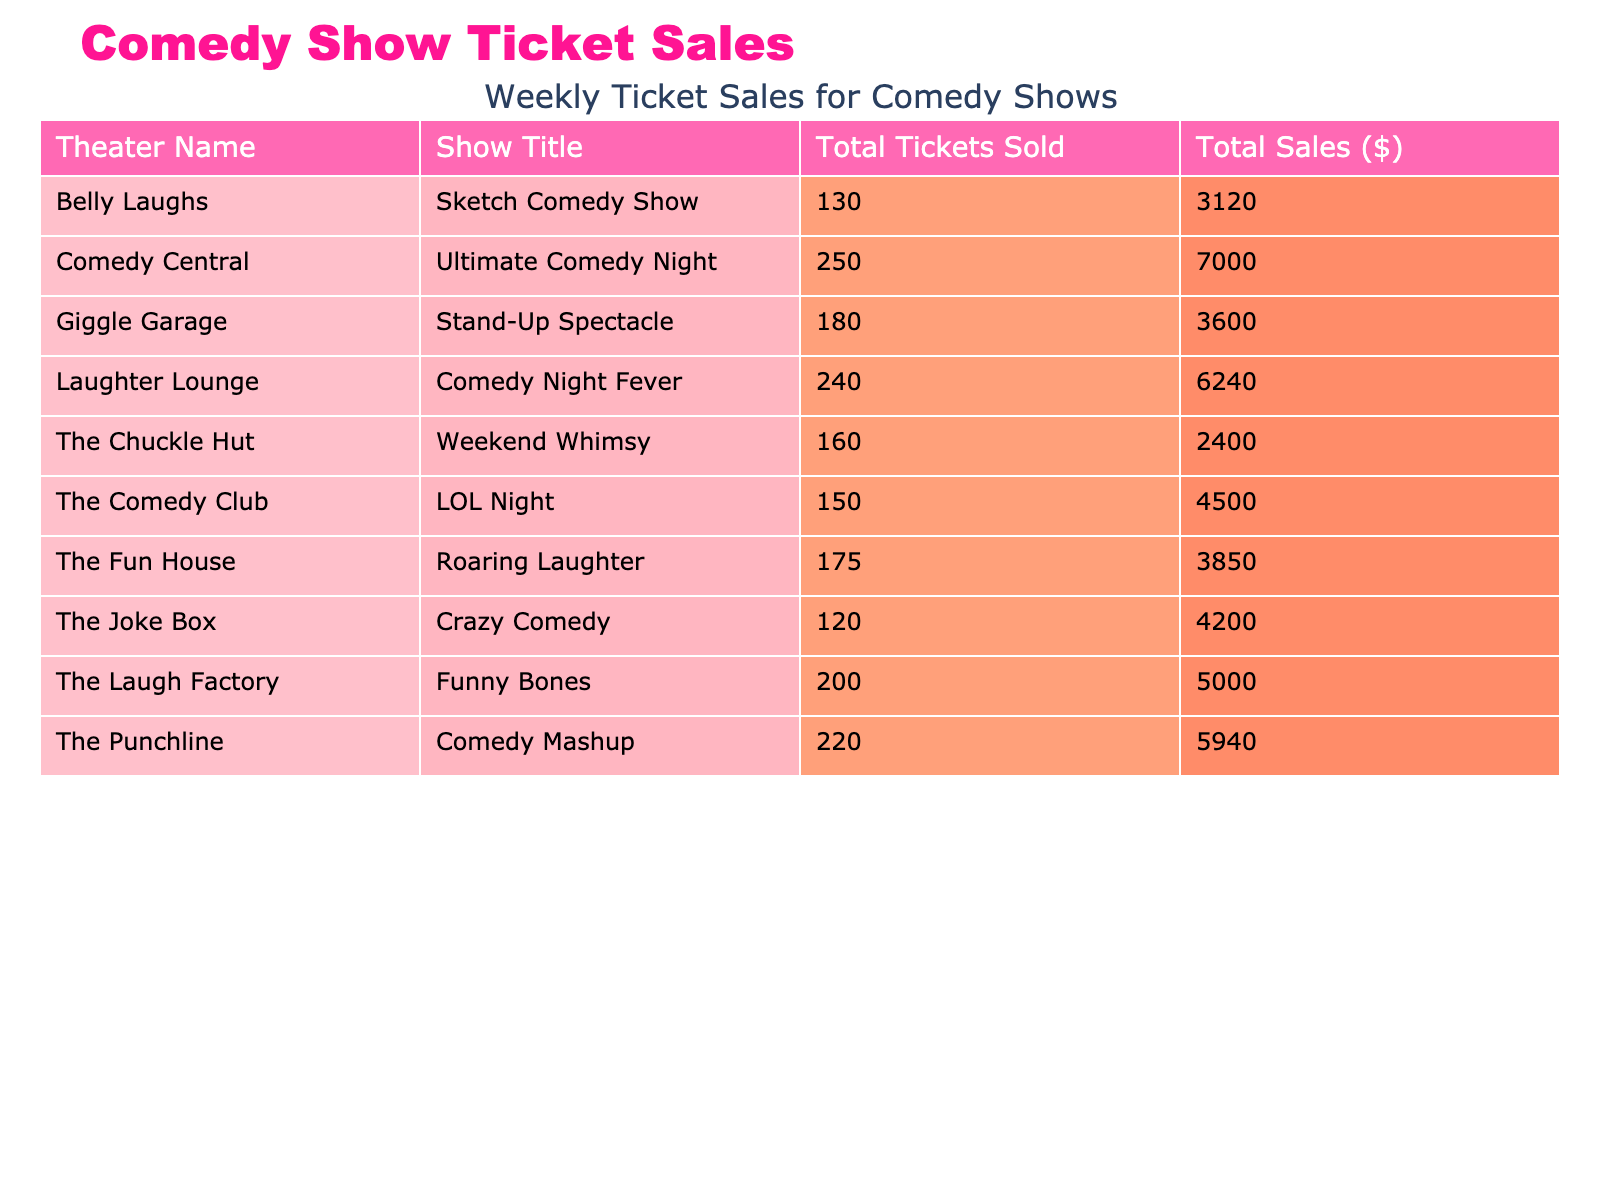What is the total number of tickets sold across all theaters? To find the total tickets sold, I will add the total tickets sold for each theater: 200 + 150 + 180 + 220 + 120 + 160 + 250 + 175 + 240 + 130 = 1885.
Answer: 1885 Which theater had the highest total sales? By reviewing the total sales for each theater, I see that Comedy Central had total sales of $7000, which is higher than any other theater listed.
Answer: Comedy Central What is the average ticket price for all shows? I will calculate the average ticket price by summing all ticket prices (25 + 30 + 20 + 27 + 35 + 15 + 28 + 22 + 26 + 24) =  252 and dividing by the number of shows (10). The average ticket price is $252 / 10 = $25.20.
Answer: 25.20 Did The Punchline sell more than 200 tickets? The Punchline sold a total of 220 tickets, which is greater than 200, making this statement true.
Answer: Yes What is the total sales value for shows located in Los Angeles and New York combined? I will add the total sales from these two locations. For Los Angeles (The Laugh Factory) it is $5000, and for New York (The Comedy Club) it is $4500. The sum is $5000 + $4500 = $9500.
Answer: 9500 Which show sold the least number of tickets? Upon reviewing the total tickets sold, The Joke Box sold the least tickets with a total of 120.
Answer: 120 What percentage of total tickets sold did Comedy Central represent? To find the percentage, I first note that Comedy Central sold 250 tickets. I then calculate the total tickets sold (1885) and find the percentage as (250 / 1885) * 100, which results in approximately 13.27%.
Answer: 13.27% Which theater had the most total tickets sold, and how many did they sell? Comparing the total tickets sold for each theater, Comedy Central leads with 250 tickets sold, making it the highest seller.
Answer: Comedy Central, 250 What is the difference in total sales between the theater with the highest and lowest total sales? Comedy Central had the highest total sales at $7000, and The Chuckle Hut had the lowest at $2400. The difference is $7000 - $2400 = $4600.
Answer: 4600 